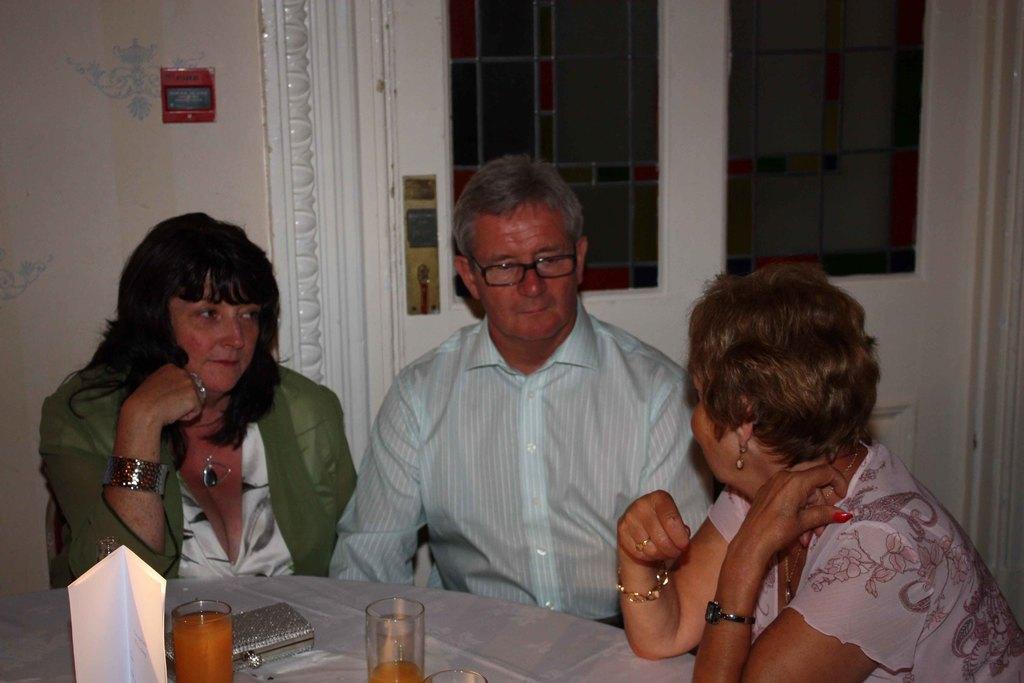In one or two sentences, can you explain what this image depicts? This is a picture taken in a room, three people were sitting on the chair in front of the three people there is a table on the table there is a wallet and two glasses background of two people there is door which is in white color. 